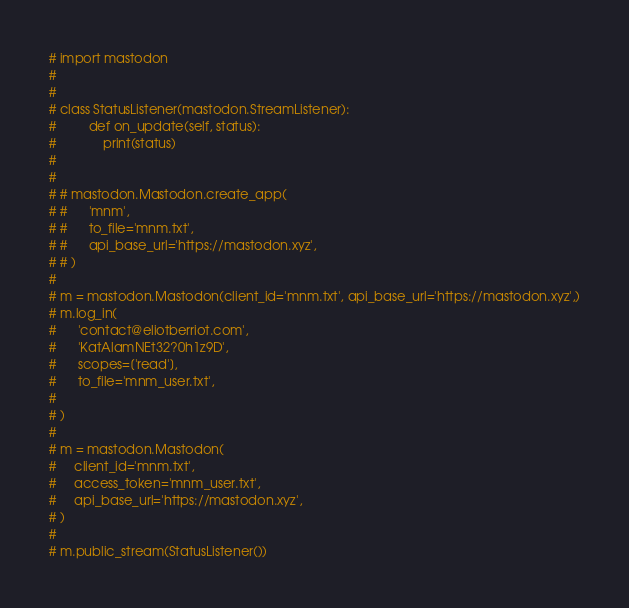<code> <loc_0><loc_0><loc_500><loc_500><_Python_># import mastodon
#
#
# class StatusListener(mastodon.StreamListener):
#         def on_update(self, status):
#             print(status)
#
#
# # mastodon.Mastodon.create_app(
# #      'mnm',
# #      to_file='mnm.txt',
# #      api_base_url='https://mastodon.xyz',
# # )
#
# m = mastodon.Mastodon(client_id='mnm.txt', api_base_url='https://mastodon.xyz',)
# m.log_in(
#      'contact@eliotberriot.com',
#      'KatAlamNEt32?0h1z9D',
#      scopes=['read'],
#      to_file='mnm_user.txt',
#
# )
#
# m = mastodon.Mastodon(
#     client_id='mnm.txt',
#     access_token='mnm_user.txt',
#     api_base_url='https://mastodon.xyz',
# )
#
# m.public_stream(StatusListener())
</code> 